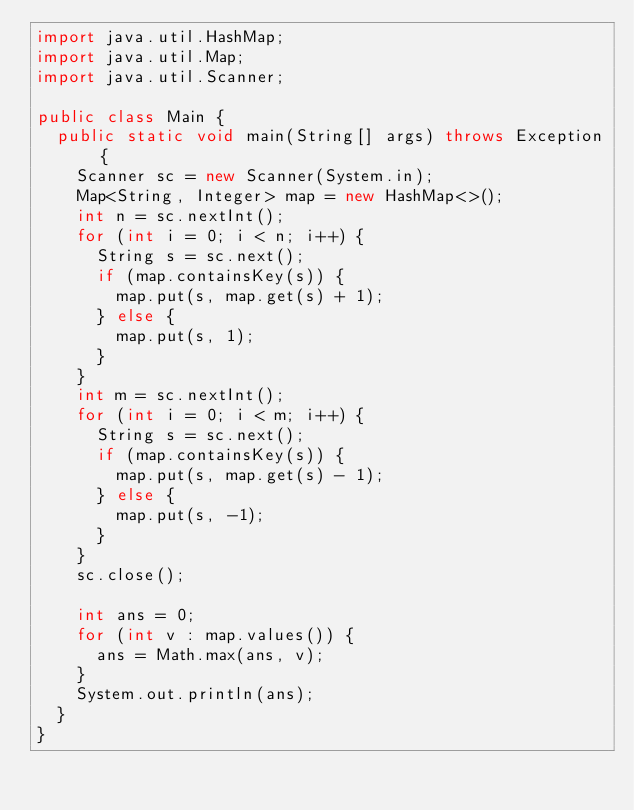Convert code to text. <code><loc_0><loc_0><loc_500><loc_500><_Java_>import java.util.HashMap;
import java.util.Map;
import java.util.Scanner;

public class Main {
	public static void main(String[] args) throws Exception {
		Scanner sc = new Scanner(System.in);
		Map<String, Integer> map = new HashMap<>();
		int n = sc.nextInt();
		for (int i = 0; i < n; i++) {
			String s = sc.next();
			if (map.containsKey(s)) {
				map.put(s, map.get(s) + 1);
			} else {
				map.put(s, 1);
			}
		}
		int m = sc.nextInt();
		for (int i = 0; i < m; i++) {
			String s = sc.next();
			if (map.containsKey(s)) {
				map.put(s, map.get(s) - 1);
			} else {
				map.put(s, -1);
			}
		}
		sc.close();

		int ans = 0;
		for (int v : map.values()) {
			ans = Math.max(ans, v);
		}
		System.out.println(ans);
	}
}
</code> 